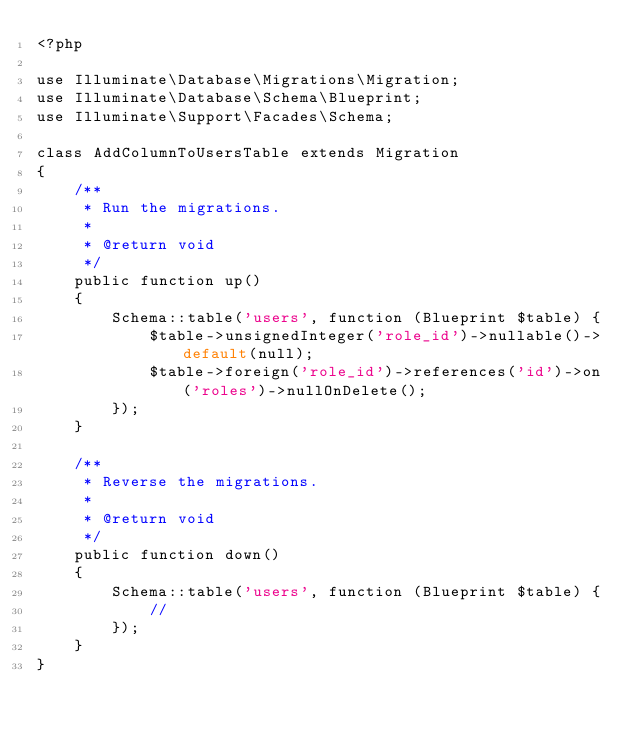<code> <loc_0><loc_0><loc_500><loc_500><_PHP_><?php

use Illuminate\Database\Migrations\Migration;
use Illuminate\Database\Schema\Blueprint;
use Illuminate\Support\Facades\Schema;

class AddColumnToUsersTable extends Migration
{
    /**
     * Run the migrations.
     *
     * @return void
     */
    public function up()
    {
        Schema::table('users', function (Blueprint $table) { 
            $table->unsignedInteger('role_id')->nullable()->default(null);
            $table->foreign('role_id')->references('id')->on('roles')->nullOnDelete();
        });
    }

    /**
     * Reverse the migrations.
     *
     * @return void
     */
    public function down()
    {
        Schema::table('users', function (Blueprint $table) {
            //
        });
    }
}
</code> 